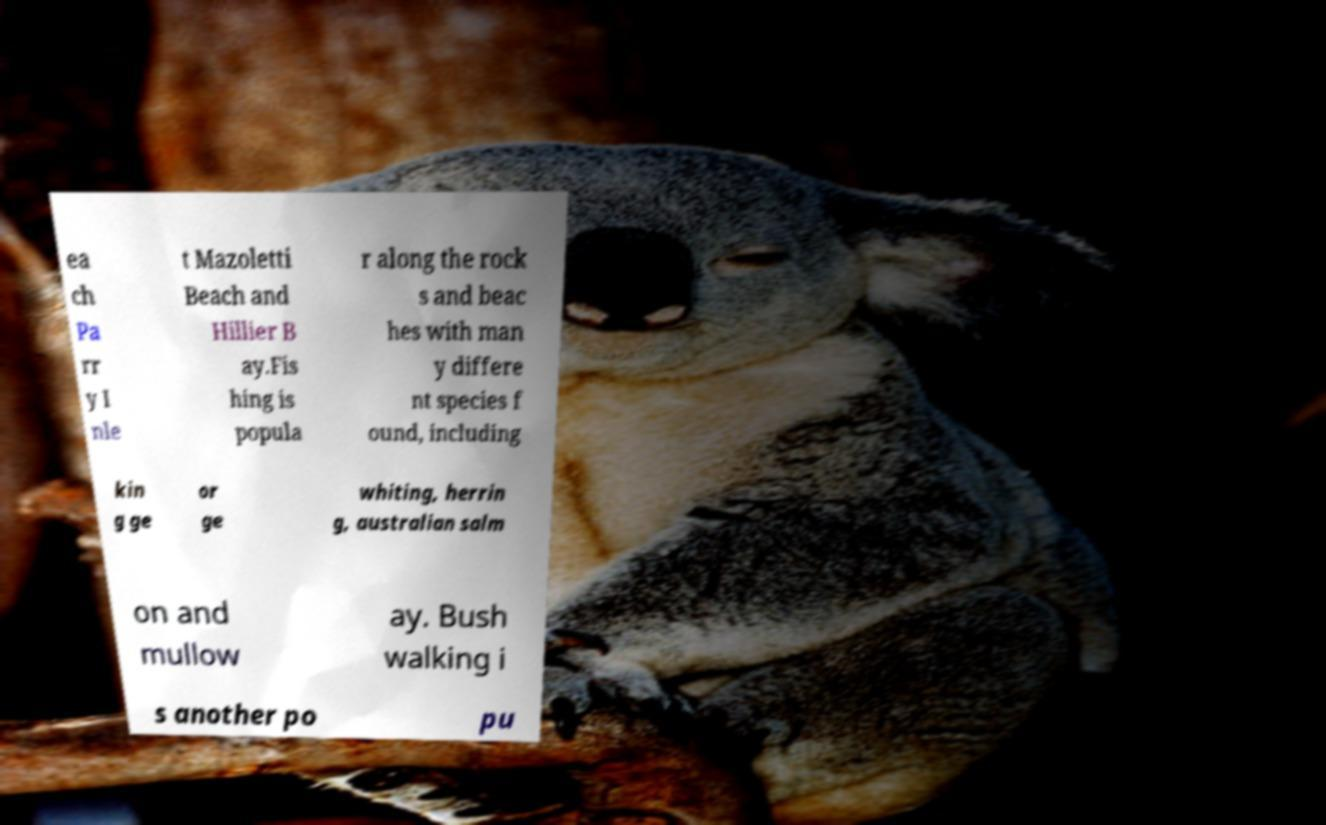Could you assist in decoding the text presented in this image and type it out clearly? ea ch Pa rr y I nle t Mazoletti Beach and Hillier B ay.Fis hing is popula r along the rock s and beac hes with man y differe nt species f ound, including kin g ge or ge whiting, herrin g, australian salm on and mullow ay. Bush walking i s another po pu 